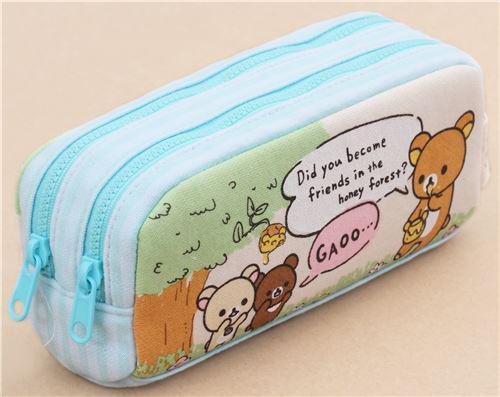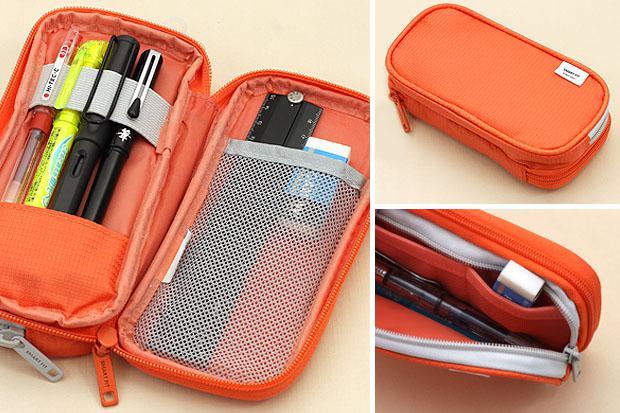The first image is the image on the left, the second image is the image on the right. Considering the images on both sides, is "The left-hand image shows a double-zipper topped pencil case featuring sky-blue color." valid? Answer yes or no. Yes. The first image is the image on the left, the second image is the image on the right. Assess this claim about the two images: "There is a human hand touching a pencil case in one of the images.". Correct or not? Answer yes or no. No. 